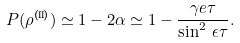<formula> <loc_0><loc_0><loc_500><loc_500>P ( \rho ^ { \text {(II)} } ) \simeq 1 - 2 \alpha \simeq 1 - \frac { \gamma e \tau } { \sin ^ { 2 } \, \epsilon \tau } .</formula> 